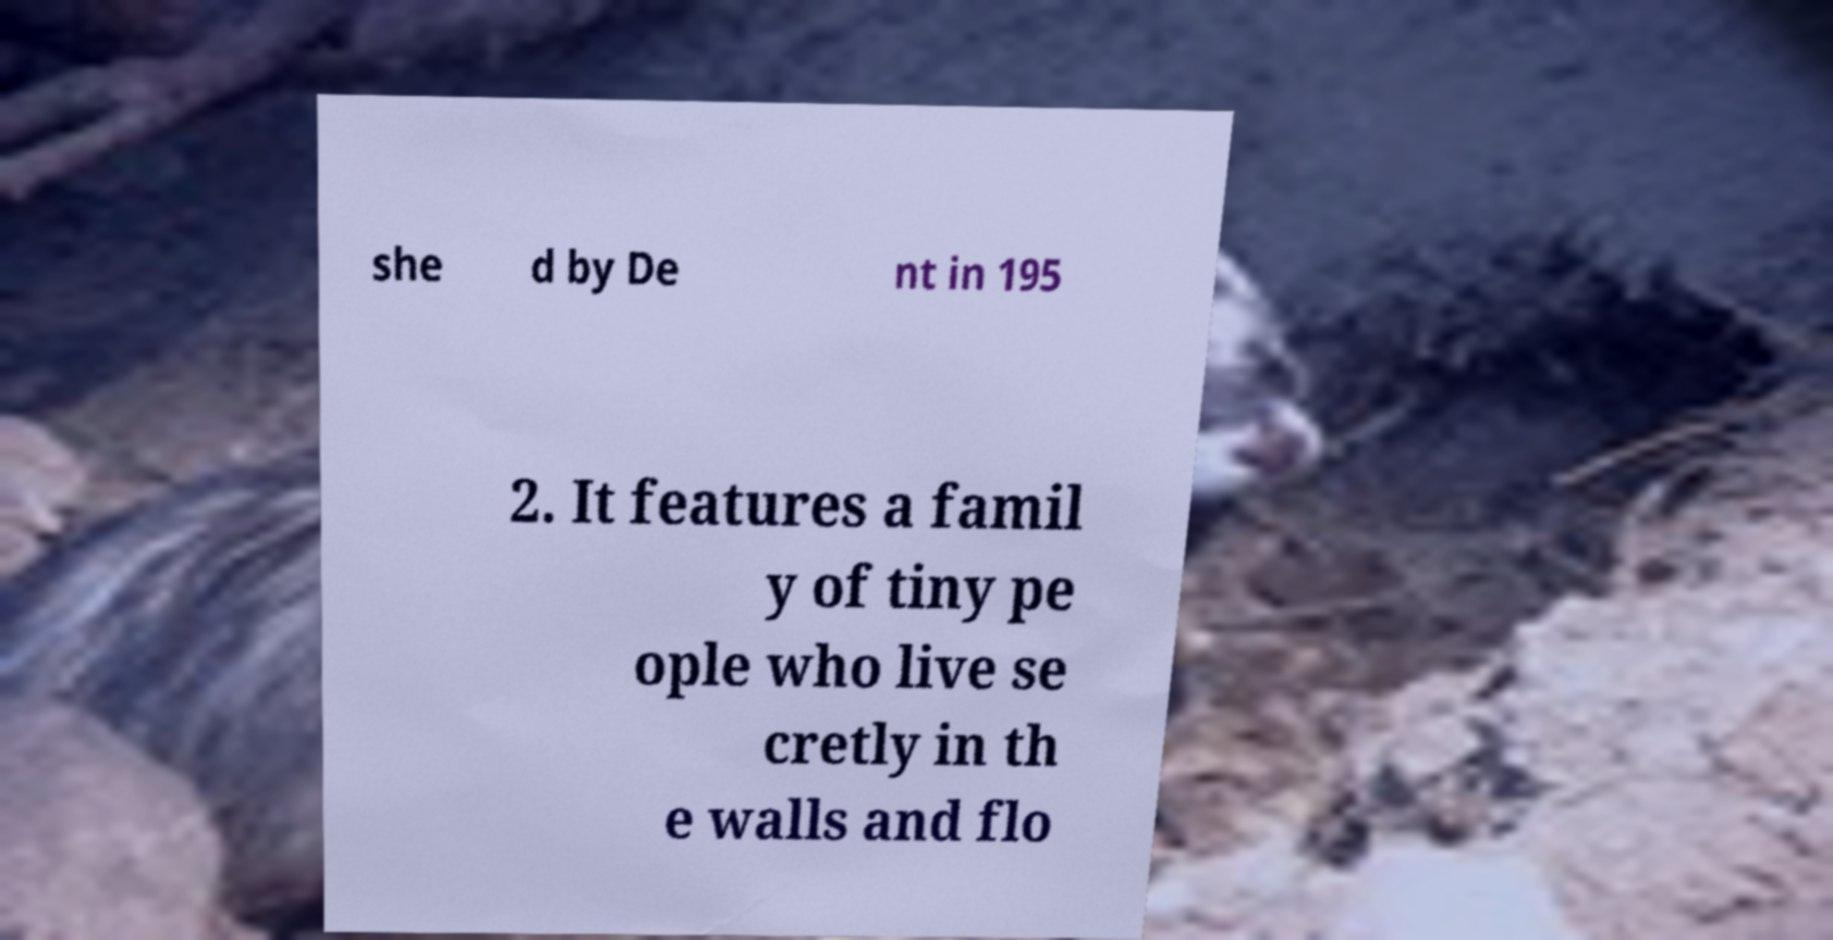I need the written content from this picture converted into text. Can you do that? she d by De nt in 195 2. It features a famil y of tiny pe ople who live se cretly in th e walls and flo 